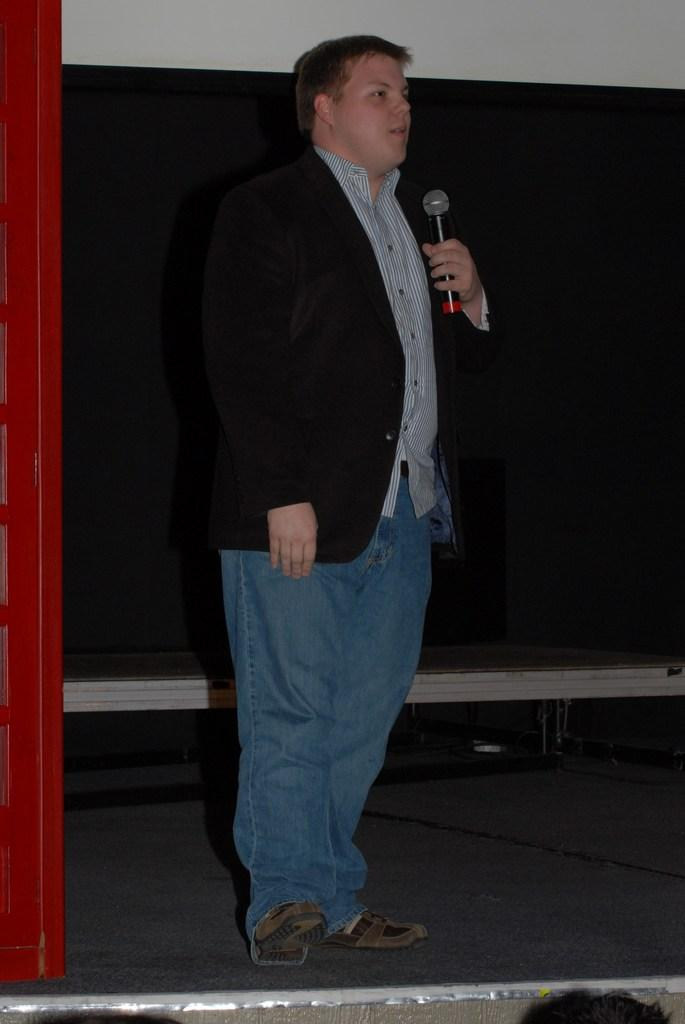What is the main subject of the image? The main subject of the image is a man. What is the man doing in the image? The man is standing in the image. What object is the man holding in the image? The man is holding a mic in the image. What type of level can be seen in the image? There is no level present in the image. What type of bat is the man holding in the image? There is no bat present in the image; the man is holding a mic. 